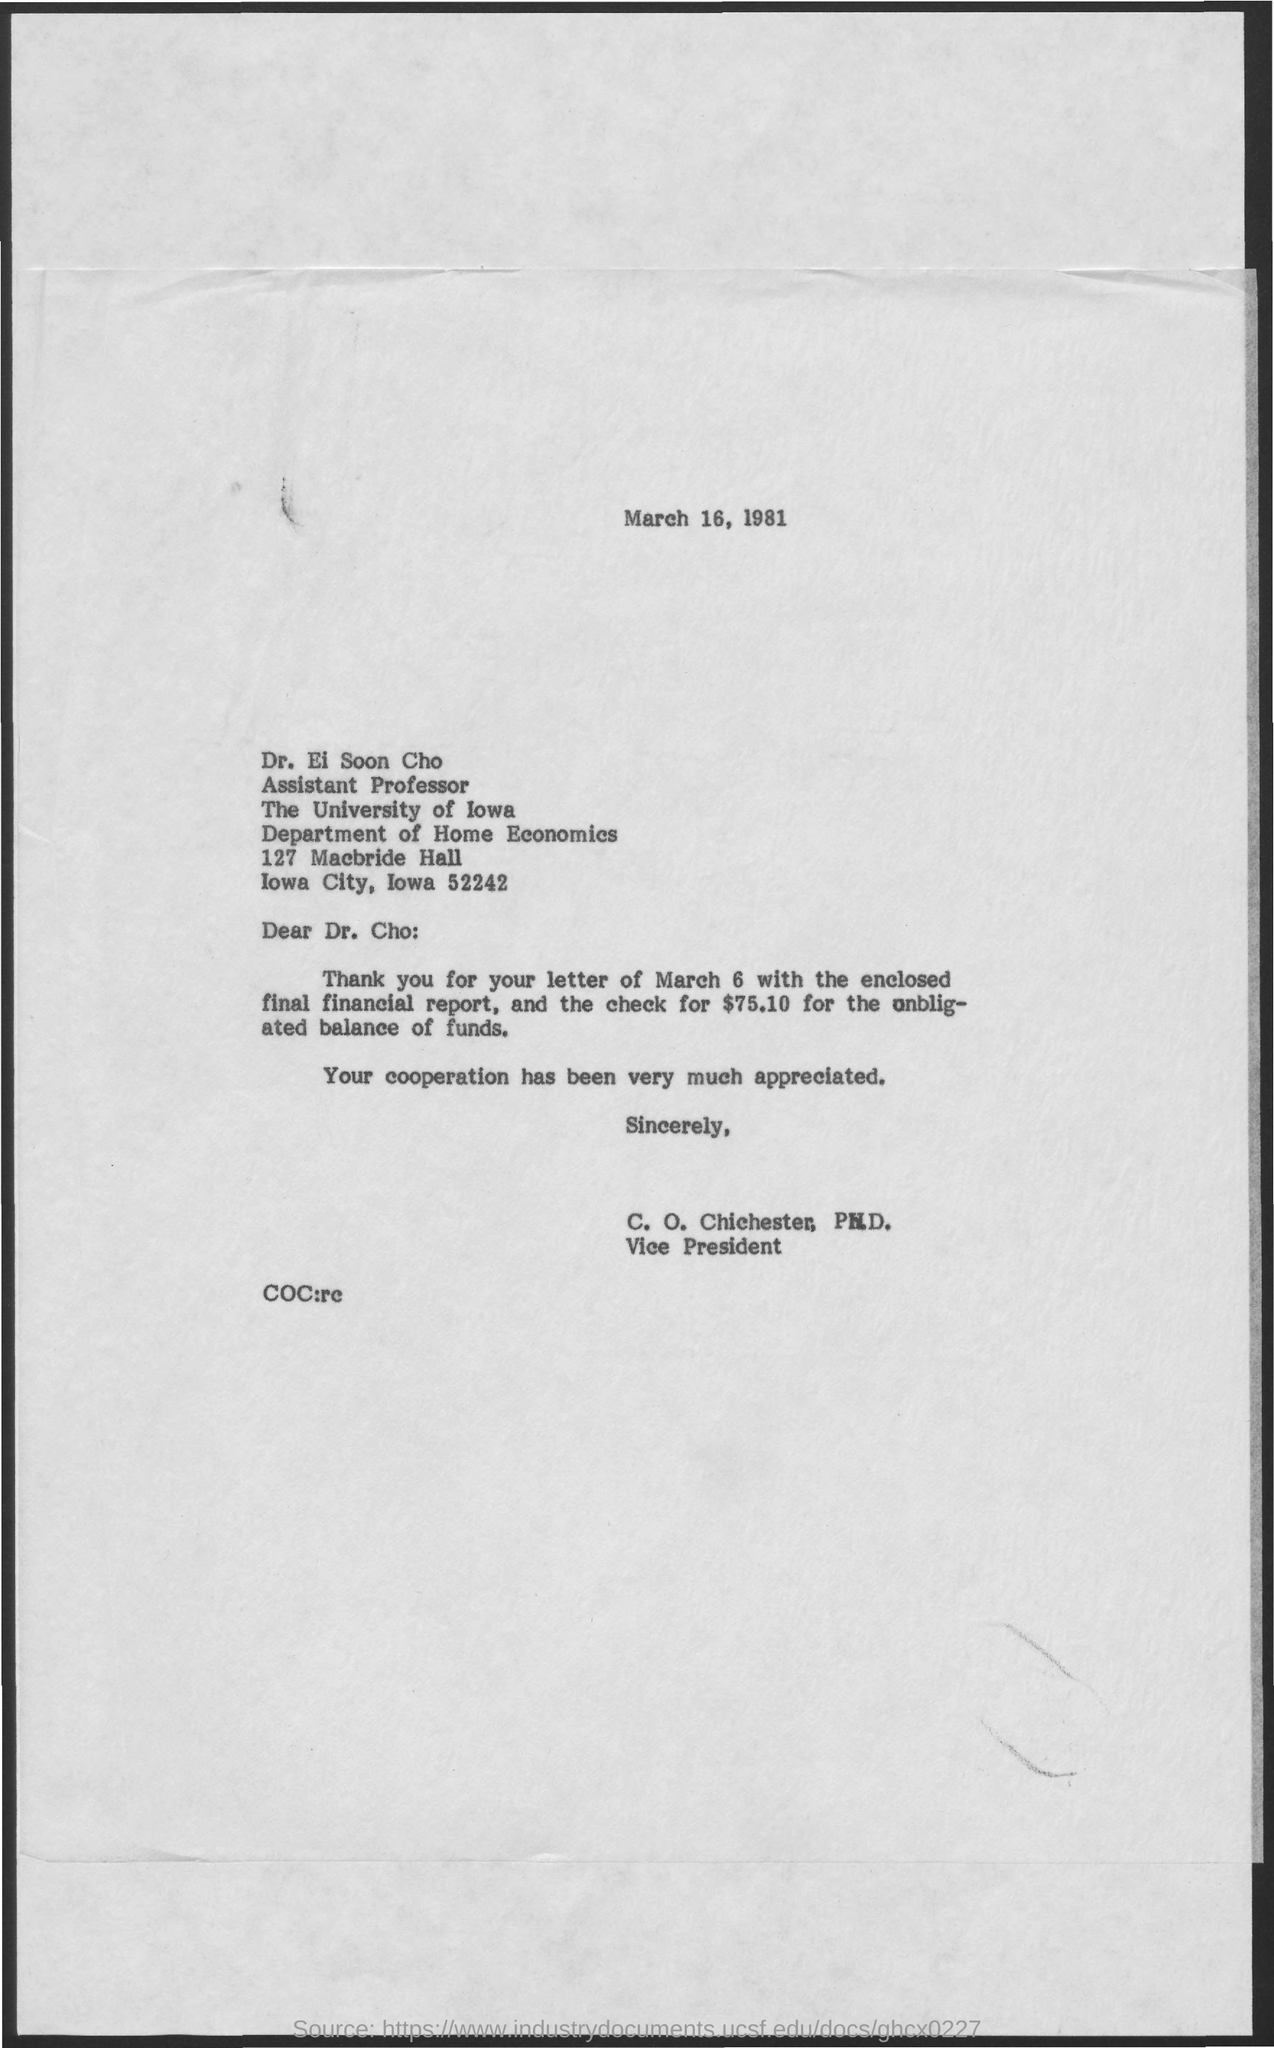Give some essential details in this illustration. The date on the document is March 16, 1981. I received a check for $75.10. The letter is addressed to Dr. Ei Soon Cho. The letter is from C. O. Chichester, Ph.D. 